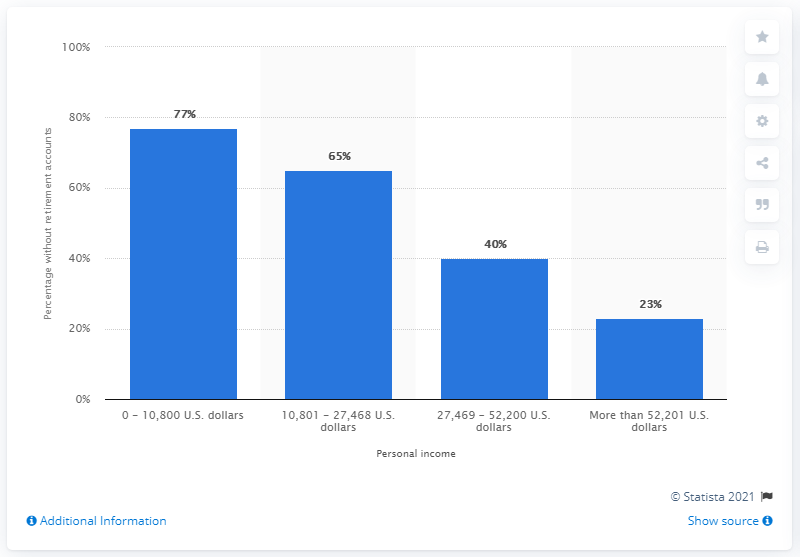Specify some key components in this picture. Approximately 77% of Americans in the bottom 25th percentile had equivalent income levels. 